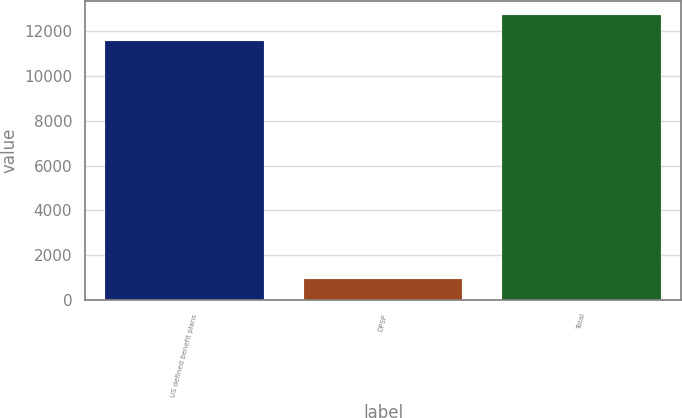Convert chart. <chart><loc_0><loc_0><loc_500><loc_500><bar_chart><fcel>US defined benefit plans<fcel>DPSP<fcel>Total<nl><fcel>11536<fcel>958<fcel>12689.6<nl></chart> 